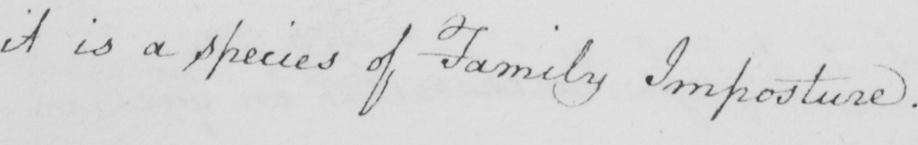Can you tell me what this handwritten text says? it is a species of Family Imposture . 